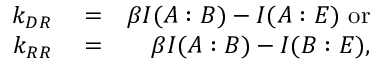<formula> <loc_0><loc_0><loc_500><loc_500>\begin{array} { r l r } { k _ { D R } } & = } & { \beta I ( A \colon B ) - I ( A \colon E ) \ { o r } } \\ { k _ { R R } } & = } & { \beta I ( A \colon B ) - I ( B \colon E ) , } \end{array}</formula> 